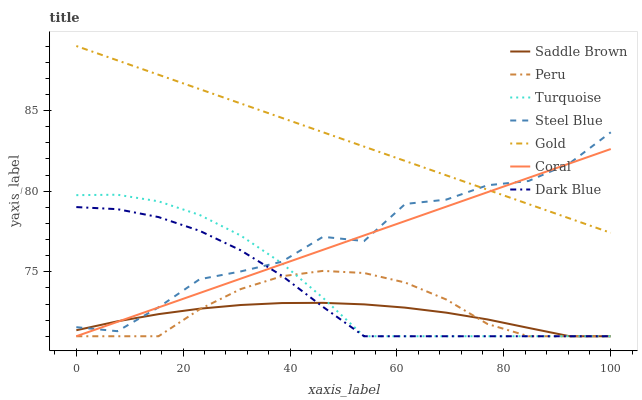Does Saddle Brown have the minimum area under the curve?
Answer yes or no. Yes. Does Gold have the maximum area under the curve?
Answer yes or no. Yes. Does Coral have the minimum area under the curve?
Answer yes or no. No. Does Coral have the maximum area under the curve?
Answer yes or no. No. Is Coral the smoothest?
Answer yes or no. Yes. Is Steel Blue the roughest?
Answer yes or no. Yes. Is Gold the smoothest?
Answer yes or no. No. Is Gold the roughest?
Answer yes or no. No. Does Gold have the lowest value?
Answer yes or no. No. Does Coral have the highest value?
Answer yes or no. No. Is Peru less than Gold?
Answer yes or no. Yes. Is Steel Blue greater than Peru?
Answer yes or no. Yes. Does Peru intersect Gold?
Answer yes or no. No. 